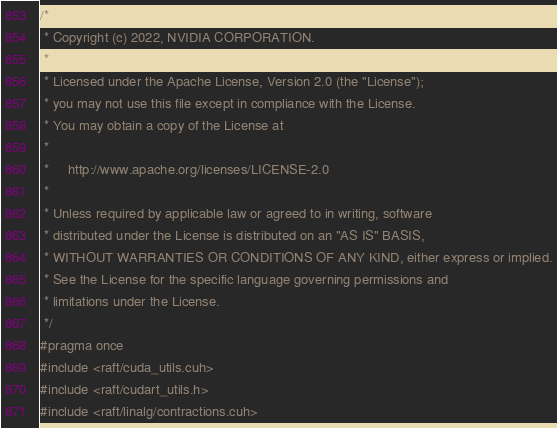Convert code to text. <code><loc_0><loc_0><loc_500><loc_500><_Cuda_>/*
 * Copyright (c) 2022, NVIDIA CORPORATION.
 *
 * Licensed under the Apache License, Version 2.0 (the "License");
 * you may not use this file except in compliance with the License.
 * You may obtain a copy of the License at
 *
 *     http://www.apache.org/licenses/LICENSE-2.0
 *
 * Unless required by applicable law or agreed to in writing, software
 * distributed under the License is distributed on an "AS IS" BASIS,
 * WITHOUT WARRANTIES OR CONDITIONS OF ANY KIND, either express or implied.
 * See the License for the specific language governing permissions and
 * limitations under the License.
 */
#pragma once
#include <raft/cuda_utils.cuh>
#include <raft/cudart_utils.h>
#include <raft/linalg/contractions.cuh></code> 